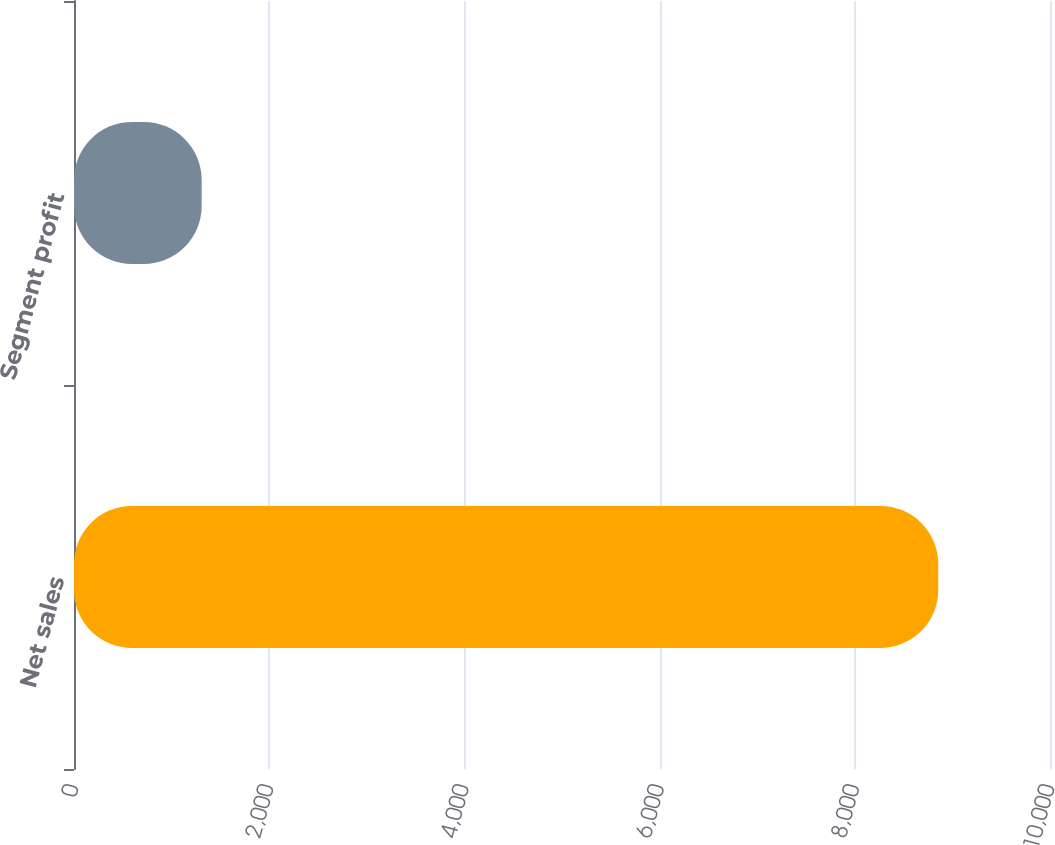Convert chart. <chart><loc_0><loc_0><loc_500><loc_500><bar_chart><fcel>Net sales<fcel>Segment profit<nl><fcel>8855<fcel>1308<nl></chart> 